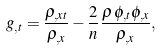Convert formula to latex. <formula><loc_0><loc_0><loc_500><loc_500>g _ { , t } = \frac { \rho _ { , x t } } { \rho _ { , x } } - \frac { 2 } { n } \frac { \rho \, \phi _ { , t } \phi _ { , x } } { \rho _ { , x } } ,</formula> 